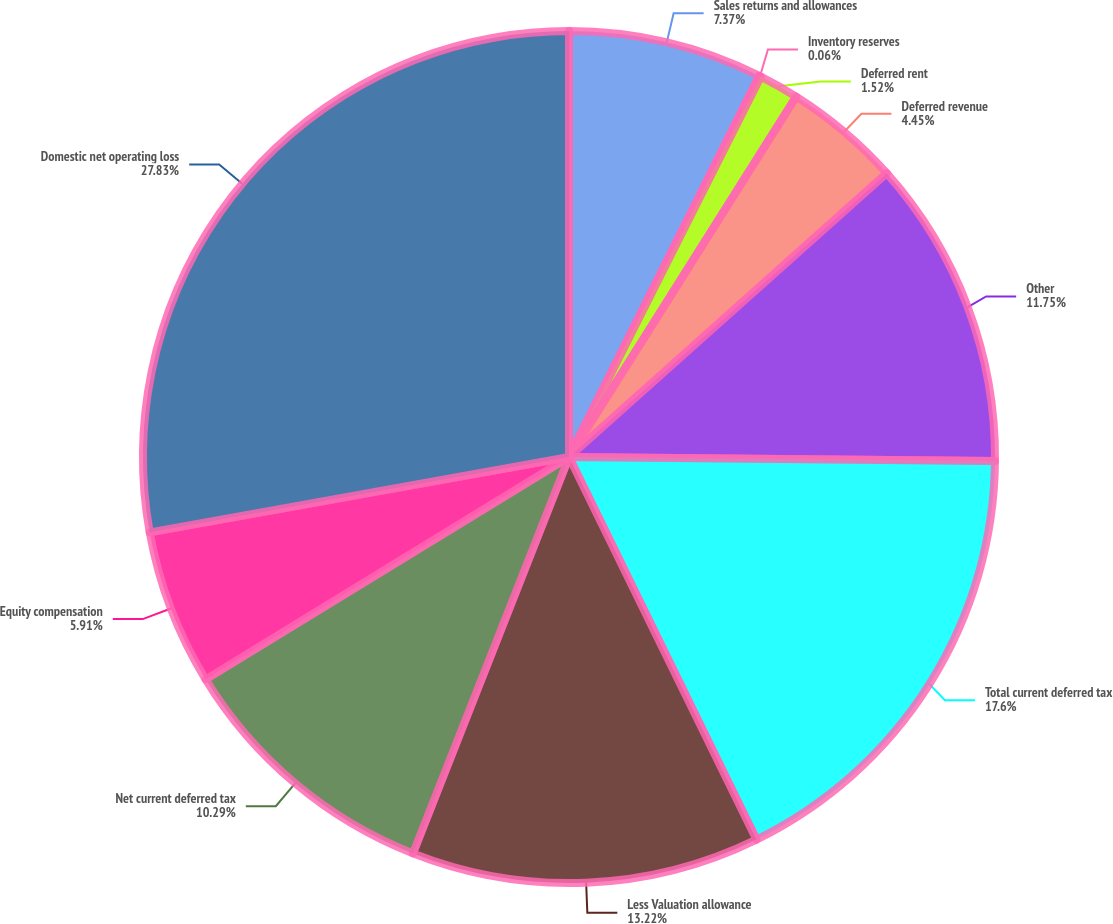<chart> <loc_0><loc_0><loc_500><loc_500><pie_chart><fcel>Sales returns and allowances<fcel>Inventory reserves<fcel>Deferred rent<fcel>Deferred revenue<fcel>Other<fcel>Total current deferred tax<fcel>Less Valuation allowance<fcel>Net current deferred tax<fcel>Equity compensation<fcel>Domestic net operating loss<nl><fcel>7.37%<fcel>0.06%<fcel>1.52%<fcel>4.45%<fcel>11.75%<fcel>17.6%<fcel>13.22%<fcel>10.29%<fcel>5.91%<fcel>27.83%<nl></chart> 